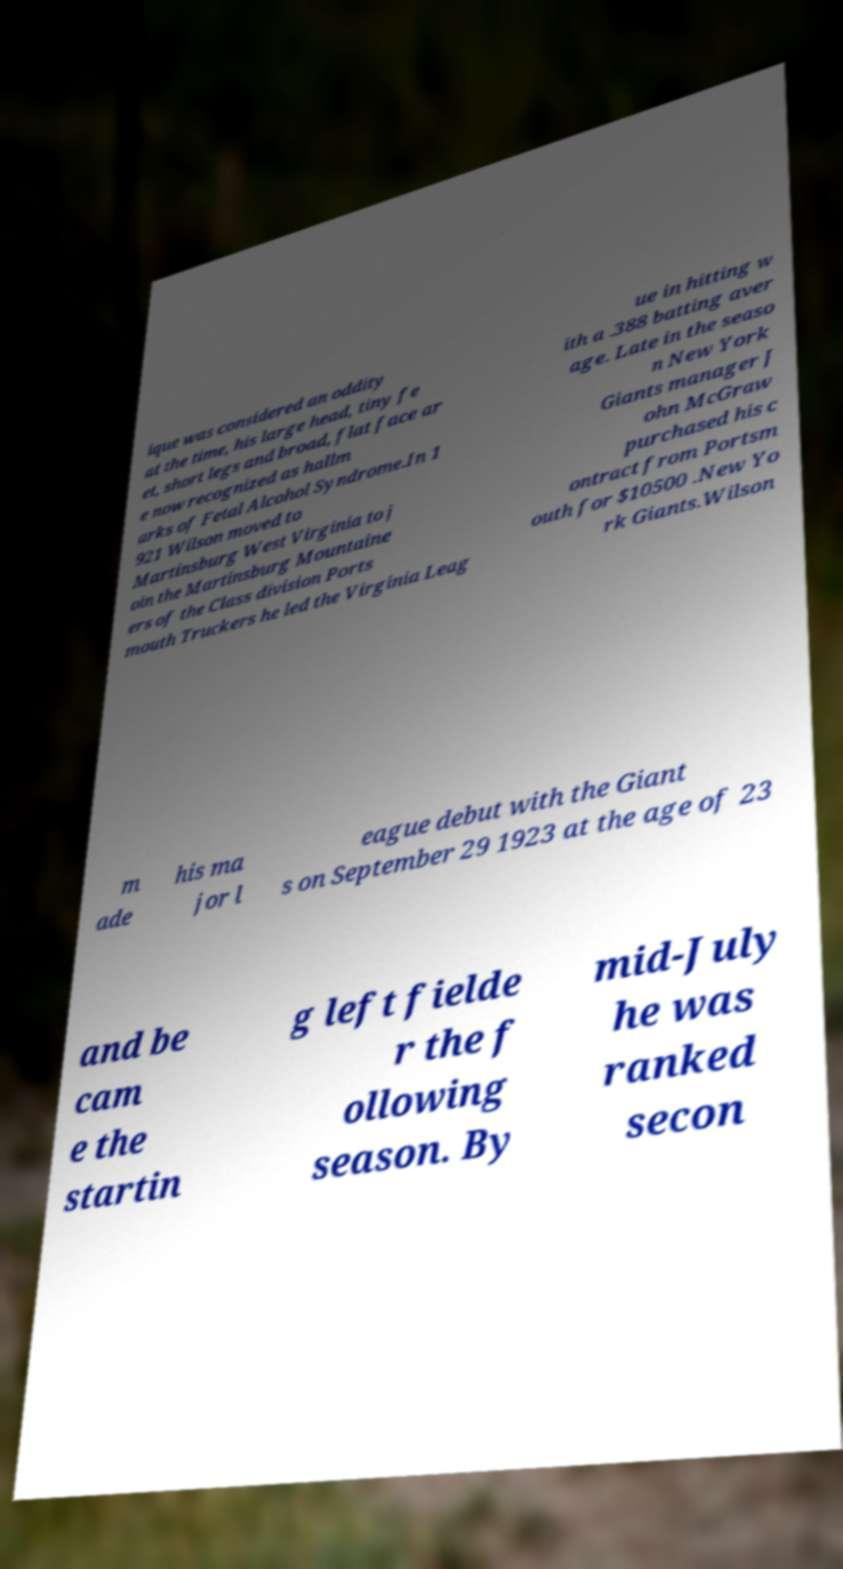For documentation purposes, I need the text within this image transcribed. Could you provide that? ique was considered an oddity at the time, his large head, tiny fe et, short legs and broad, flat face ar e now recognized as hallm arks of Fetal Alcohol Syndrome.In 1 921 Wilson moved to Martinsburg West Virginia to j oin the Martinsburg Mountaine ers of the Class division Ports mouth Truckers he led the Virginia Leag ue in hitting w ith a .388 batting aver age. Late in the seaso n New York Giants manager J ohn McGraw purchased his c ontract from Portsm outh for $10500 .New Yo rk Giants.Wilson m ade his ma jor l eague debut with the Giant s on September 29 1923 at the age of 23 and be cam e the startin g left fielde r the f ollowing season. By mid-July he was ranked secon 